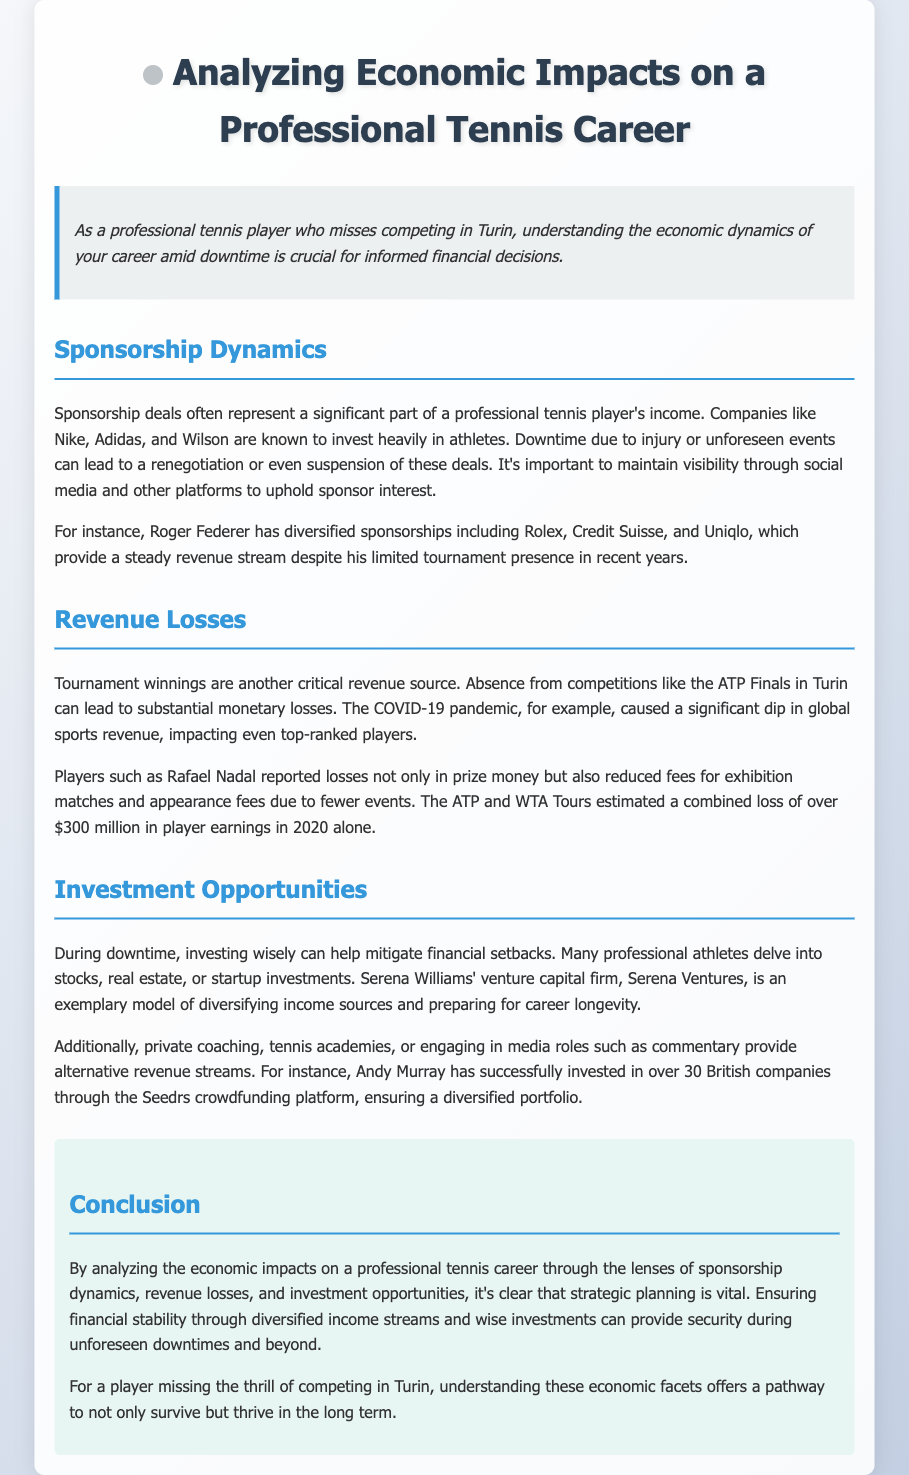What type of companies are mentioned as sponsors? The document mentions Nike, Adidas, and Wilson as companies that invest heavily in athletes.
Answer: Nike, Adidas, and Wilson What was the combined loss of player earnings in 2020? The ATP and WTA Tours estimated a combined loss of over $300 million in player earnings during the pandemic.
Answer: $300 million Which tennis player has a venture capital firm? Serena Williams is mentioned in the document as having a venture capital firm called Serena Ventures.
Answer: Serena Williams What impact did COVID-19 have on sports revenue? The document states that the COVID-19 pandemic caused a significant dip in global sports revenue.
Answer: Significant dip Which player reported losses in tournament winnings and fees? Rafael Nadal is specifically mentioned as reporting losses due to pandemic-related absences.
Answer: Rafael Nadal What is essential for maintaining sponsor interest? The document highlights the importance of maintaining visibility through social media and other platforms for upholding sponsor interest.
Answer: Visibility What are alternative revenue streams suggested during downtime? The document mentions private coaching, tennis academies, and media roles as alternative revenue streams.
Answer: Private coaching, tennis academies, and media roles What is the title of the case study? The title of the case study is "Analyzing Economic Impacts on a Professional Tennis Career."
Answer: Analyzing Economic Impacts on a Professional Tennis Career Which player has invested in over 30 British companies? Andy Murray is noted for having invested in over 30 British companies through the Seedrs crowdfunding platform.
Answer: Andy Murray 